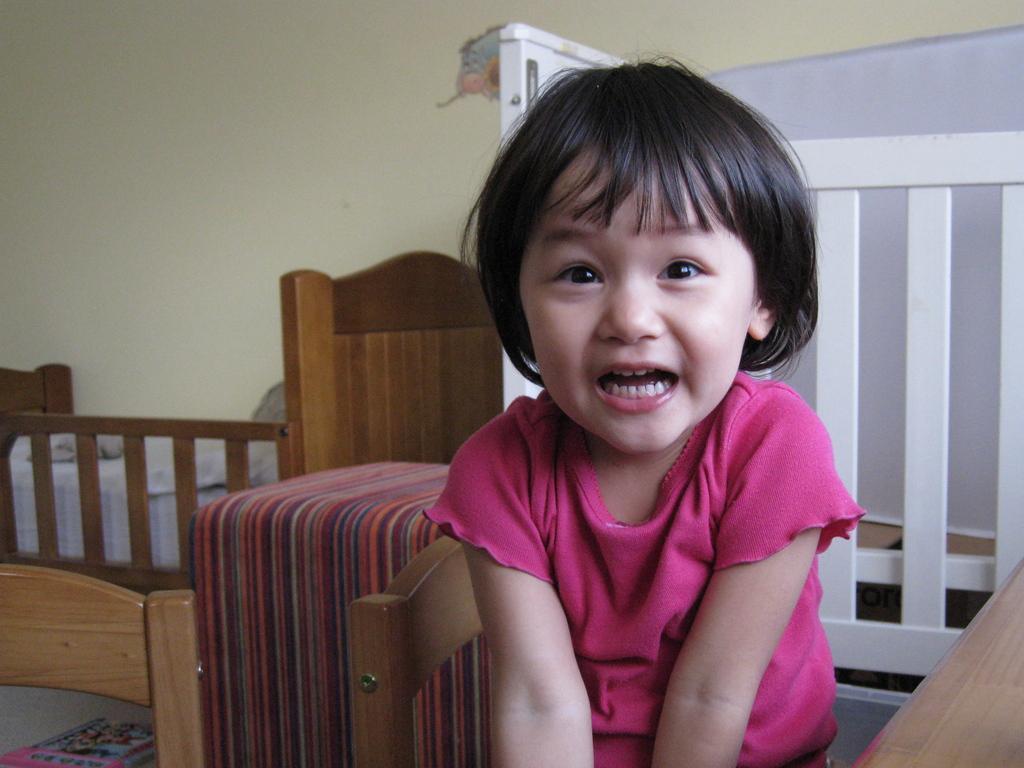Could you give a brief overview of what you see in this image? A girl wearing a pink dress is smiling. There are bed, cot and a white color fencing. In the background there is a wall. 